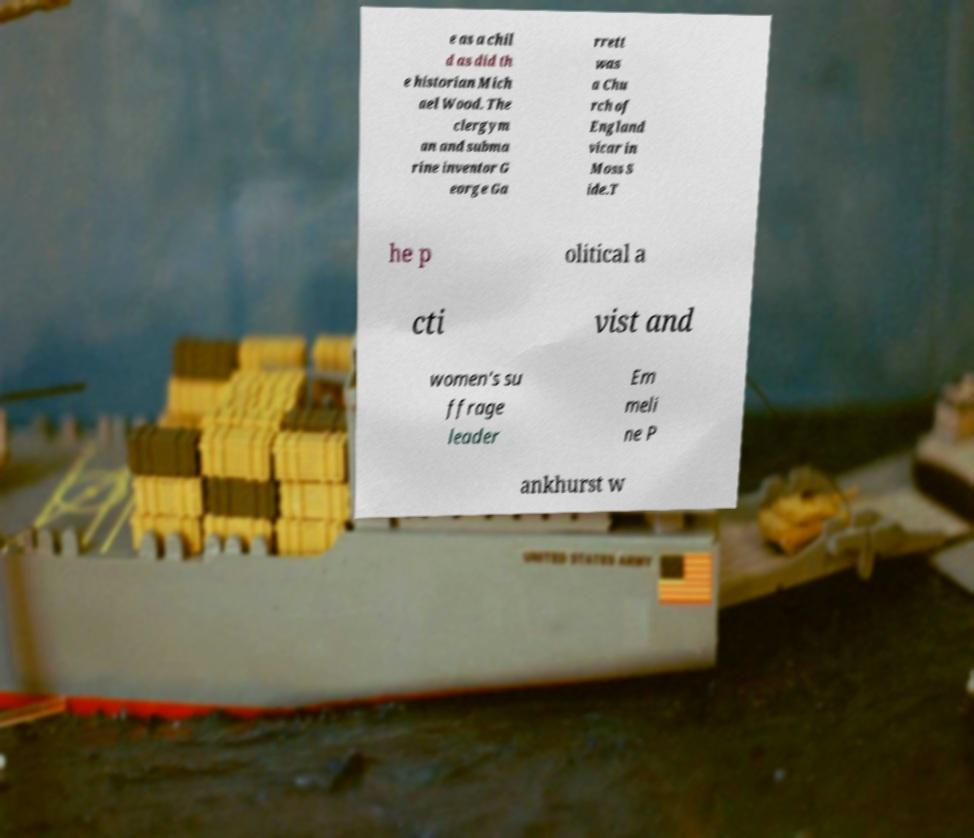Please identify and transcribe the text found in this image. e as a chil d as did th e historian Mich ael Wood. The clergym an and subma rine inventor G eorge Ga rrett was a Chu rch of England vicar in Moss S ide.T he p olitical a cti vist and women's su ffrage leader Em meli ne P ankhurst w 